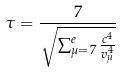Convert formula to latex. <formula><loc_0><loc_0><loc_500><loc_500>\tau = \frac { 7 } { \sqrt { \sum _ { \mu = 7 } ^ { e } \frac { c ^ { 4 } } { v _ { \mu } ^ { 4 } } } }</formula> 